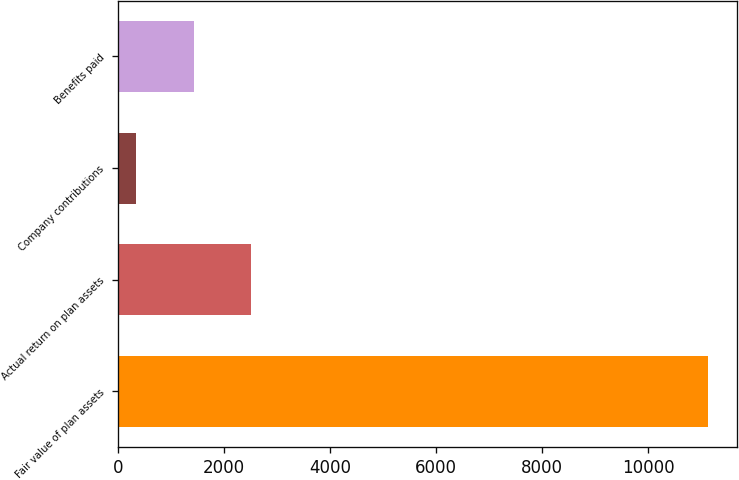Convert chart. <chart><loc_0><loc_0><loc_500><loc_500><bar_chart><fcel>Fair value of plan assets<fcel>Actual return on plan assets<fcel>Company contributions<fcel>Benefits paid<nl><fcel>11125<fcel>2502.6<fcel>347<fcel>1424.8<nl></chart> 